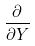Convert formula to latex. <formula><loc_0><loc_0><loc_500><loc_500>\frac { \partial } { \partial Y }</formula> 